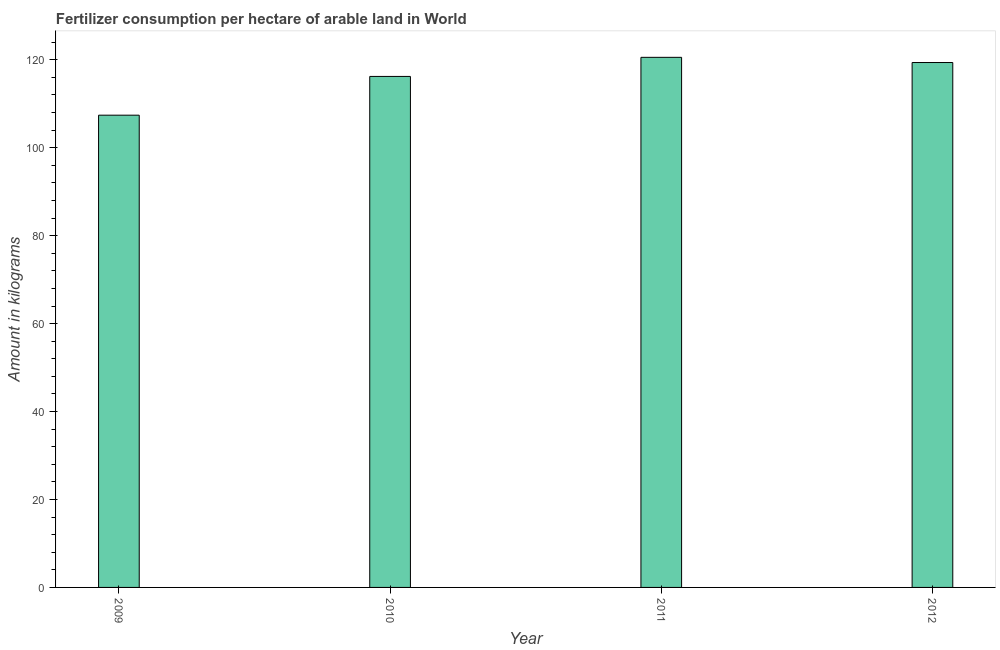Does the graph contain grids?
Offer a very short reply. No. What is the title of the graph?
Offer a very short reply. Fertilizer consumption per hectare of arable land in World . What is the label or title of the Y-axis?
Your answer should be very brief. Amount in kilograms. What is the amount of fertilizer consumption in 2011?
Provide a succinct answer. 120.55. Across all years, what is the maximum amount of fertilizer consumption?
Your response must be concise. 120.55. Across all years, what is the minimum amount of fertilizer consumption?
Provide a short and direct response. 107.4. In which year was the amount of fertilizer consumption maximum?
Your answer should be compact. 2011. In which year was the amount of fertilizer consumption minimum?
Your answer should be very brief. 2009. What is the sum of the amount of fertilizer consumption?
Offer a terse response. 463.54. What is the difference between the amount of fertilizer consumption in 2009 and 2012?
Provide a short and direct response. -11.97. What is the average amount of fertilizer consumption per year?
Give a very brief answer. 115.88. What is the median amount of fertilizer consumption?
Your answer should be compact. 117.79. In how many years, is the amount of fertilizer consumption greater than 108 kg?
Give a very brief answer. 3. Do a majority of the years between 2009 and 2012 (inclusive) have amount of fertilizer consumption greater than 112 kg?
Your response must be concise. Yes. What is the ratio of the amount of fertilizer consumption in 2011 to that in 2012?
Your response must be concise. 1.01. Is the amount of fertilizer consumption in 2010 less than that in 2012?
Provide a succinct answer. Yes. What is the difference between the highest and the second highest amount of fertilizer consumption?
Offer a very short reply. 1.18. Is the sum of the amount of fertilizer consumption in 2009 and 2011 greater than the maximum amount of fertilizer consumption across all years?
Your response must be concise. Yes. What is the difference between the highest and the lowest amount of fertilizer consumption?
Give a very brief answer. 13.16. How many bars are there?
Provide a short and direct response. 4. What is the difference between two consecutive major ticks on the Y-axis?
Offer a terse response. 20. What is the Amount in kilograms in 2009?
Your response must be concise. 107.4. What is the Amount in kilograms of 2010?
Keep it short and to the point. 116.21. What is the Amount in kilograms in 2011?
Give a very brief answer. 120.55. What is the Amount in kilograms of 2012?
Your answer should be compact. 119.37. What is the difference between the Amount in kilograms in 2009 and 2010?
Offer a very short reply. -8.81. What is the difference between the Amount in kilograms in 2009 and 2011?
Ensure brevity in your answer.  -13.16. What is the difference between the Amount in kilograms in 2009 and 2012?
Make the answer very short. -11.97. What is the difference between the Amount in kilograms in 2010 and 2011?
Keep it short and to the point. -4.34. What is the difference between the Amount in kilograms in 2010 and 2012?
Offer a terse response. -3.16. What is the difference between the Amount in kilograms in 2011 and 2012?
Your answer should be very brief. 1.18. What is the ratio of the Amount in kilograms in 2009 to that in 2010?
Offer a very short reply. 0.92. What is the ratio of the Amount in kilograms in 2009 to that in 2011?
Give a very brief answer. 0.89. What is the ratio of the Amount in kilograms in 2010 to that in 2011?
Your answer should be very brief. 0.96. 